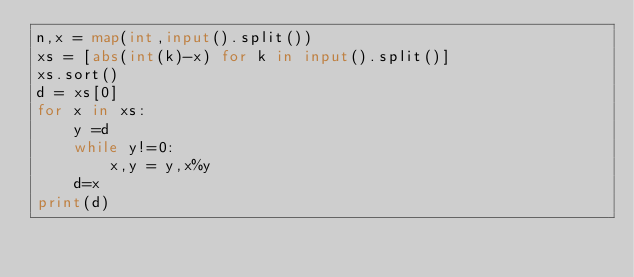Convert code to text. <code><loc_0><loc_0><loc_500><loc_500><_Python_>n,x = map(int,input().split())
xs = [abs(int(k)-x) for k in input().split()]
xs.sort()
d = xs[0]
for x in xs:
    y =d
    while y!=0:
        x,y = y,x%y        
    d=x
print(d)</code> 